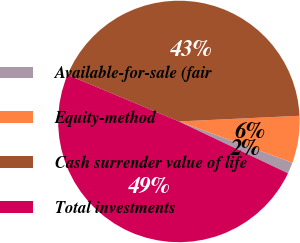Convert chart. <chart><loc_0><loc_0><loc_500><loc_500><pie_chart><fcel>Available-for-sale (fair<fcel>Equity-method<fcel>Cash surrender value of life<fcel>Total investments<nl><fcel>1.52%<fcel>6.29%<fcel>42.95%<fcel>49.24%<nl></chart> 